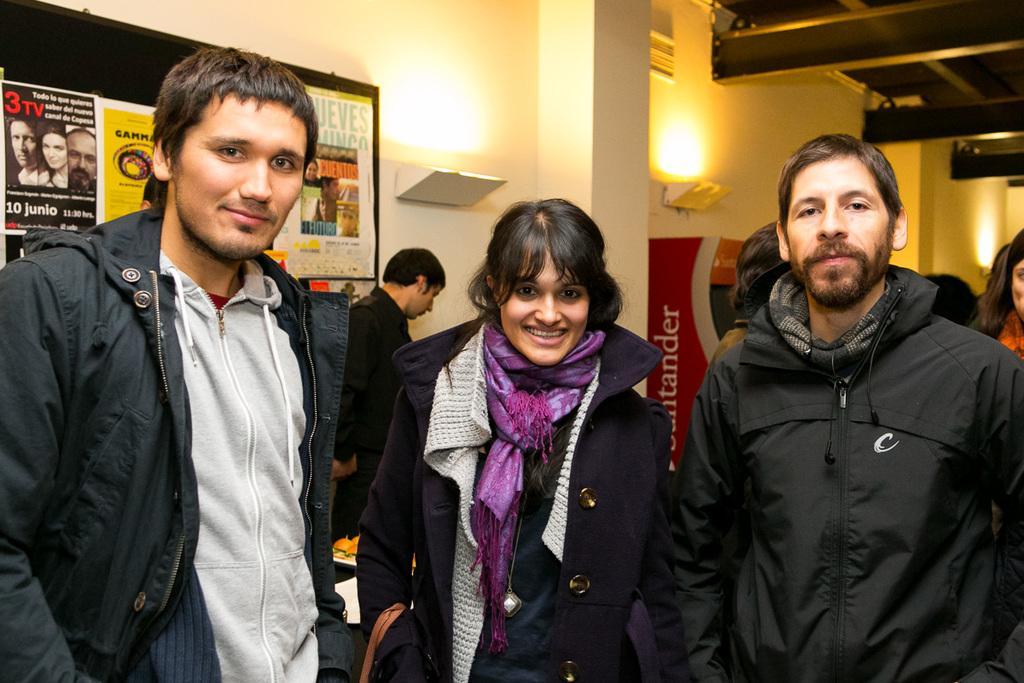Could you give a brief overview of what you see in this image? In this image we can see some people standing and we can also see posters with some text, lights and pillar. 